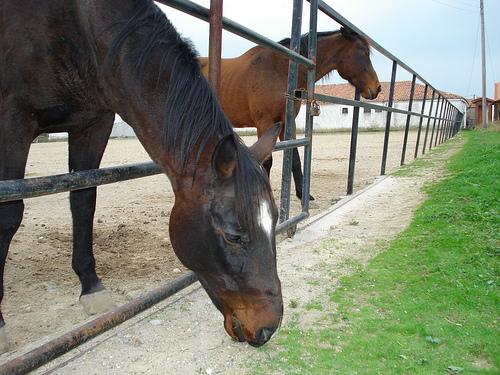Is either horse a male?
Quick response, please. Yes. What is the fence made out of?
Be succinct. Metal. How many horses are there?
Keep it brief. 2. 